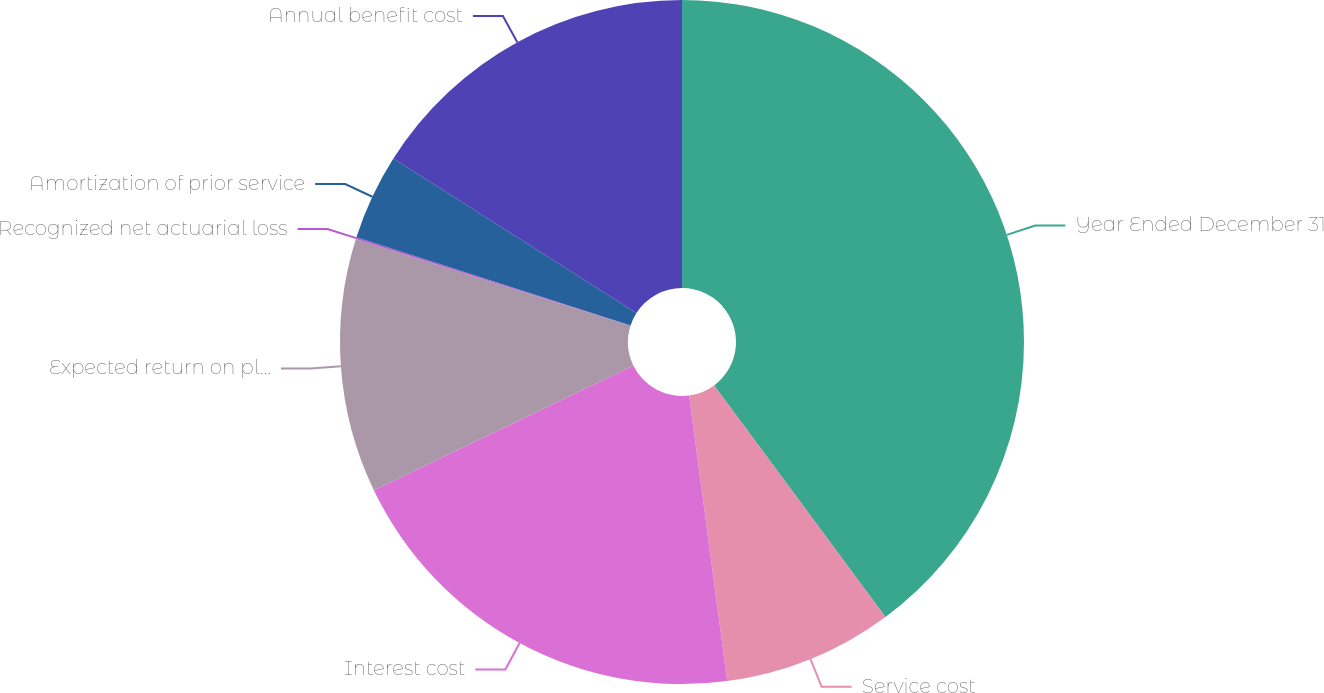<chart> <loc_0><loc_0><loc_500><loc_500><pie_chart><fcel>Year Ended December 31<fcel>Service cost<fcel>Interest cost<fcel>Expected return on plan assets<fcel>Recognized net actuarial loss<fcel>Amortization of prior service<fcel>Annual benefit cost<nl><fcel>39.86%<fcel>8.03%<fcel>19.97%<fcel>12.01%<fcel>0.08%<fcel>4.06%<fcel>15.99%<nl></chart> 